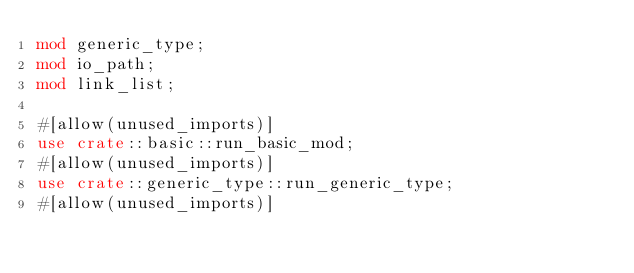<code> <loc_0><loc_0><loc_500><loc_500><_Rust_>mod generic_type;
mod io_path;
mod link_list;

#[allow(unused_imports)]
use crate::basic::run_basic_mod;
#[allow(unused_imports)]
use crate::generic_type::run_generic_type;
#[allow(unused_imports)]</code> 